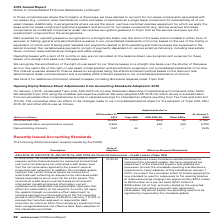According to Verizon Communications's financial document, Which Standards were Adopted on January 1, 2018? Topic 606, ASU 2018-02, Income Statement-Reporting Comprehensive Income and other ASUs.. The document states: "On January 1, 2018, we adopted Topic 606, ASU 2018-02, Income Statement-Reporting Comprehensive Income and other ASUs. We adopted Topic 606 using the ..." Also, Which method was used for adopting Topic 606? the modified retrospective method.. The document states: "Income and other ASUs. We adopted Topic 606 using the modified retrospective method. We early adopted ASU 2018-02, which allows a reclassification fro..." Also, What is the retained earnings as of December 31, 2017? According to the financial document, 35,635 (in millions). The relevant text states: "Retained earnings 35,635 2,890 (652) (6) 37,867..." Also, can you calculate: What is the change in Retained earnings from December 31, 2017 to January 1, 2018? Based on the calculation: 37,867-35,635, the result is 2232 (in millions). This is based on the information: "Retained earnings 35,635 2,890 (652) (6) 37,867 Retained earnings 35,635 2,890 (652) (6) 37,867..." The key data points involved are: 35,635, 37,867. Also, can you calculate: What is the change in Accumulated other comprehensive income from December 31, 2017 to January 1, 2018? Based on the calculation: 3,289-2,659, the result is 630 (in millions). This is based on the information: "Accumulated other comprehensive income 2,659 — 652 (22) 3,289 lated other comprehensive income 2,659 — 652 (22) 3,289..." The key data points involved are: 2,659, 3,289. Also, can you calculate: What is the change in Noncontrolling interests from December 31, 2017 to January 1, 2018? Based on the calculation: 1,635-1,591, the result is 44 (in millions). This is based on the information: "Noncontrolling interests 1,591 44 — — 1,635 Noncontrolling interests 1,591 44 — — 1,635..." The key data points involved are: 1,591, 1,635. 